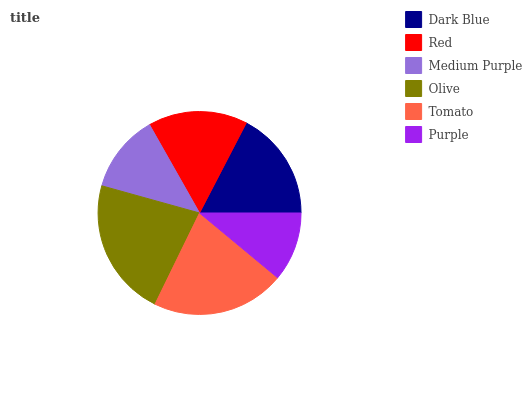Is Purple the minimum?
Answer yes or no. Yes. Is Olive the maximum?
Answer yes or no. Yes. Is Red the minimum?
Answer yes or no. No. Is Red the maximum?
Answer yes or no. No. Is Dark Blue greater than Red?
Answer yes or no. Yes. Is Red less than Dark Blue?
Answer yes or no. Yes. Is Red greater than Dark Blue?
Answer yes or no. No. Is Dark Blue less than Red?
Answer yes or no. No. Is Dark Blue the high median?
Answer yes or no. Yes. Is Red the low median?
Answer yes or no. Yes. Is Purple the high median?
Answer yes or no. No. Is Medium Purple the low median?
Answer yes or no. No. 